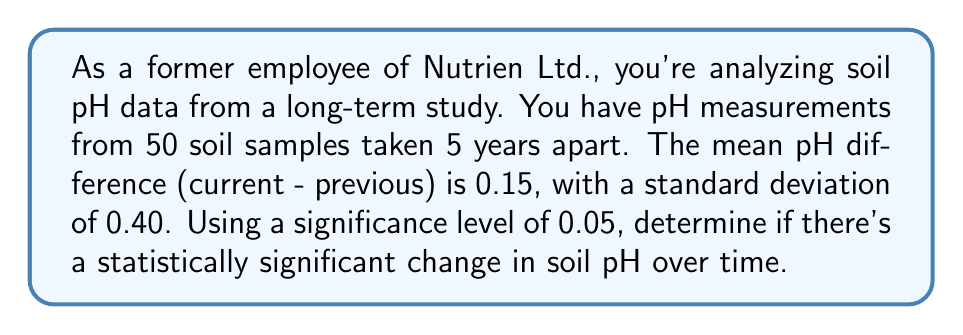Solve this math problem. To determine if there's a statistically significant change in soil pH over time, we'll use a paired t-test. Here are the steps:

1. State the hypotheses:
   $H_0: \mu_d = 0$ (null hypothesis: no significant change in pH)
   $H_a: \mu_d \neq 0$ (alternative hypothesis: significant change in pH)

2. Calculate the t-statistic:
   $t = \frac{\bar{d}}{s_d / \sqrt{n}}$
   where $\bar{d}$ is the mean difference, $s_d$ is the standard deviation of the differences, and $n$ is the sample size.

   $t = \frac{0.15}{0.40 / \sqrt{50}} = \frac{0.15}{0.0566} = 2.65$

3. Determine the critical t-value:
   For a two-tailed test with $\alpha = 0.05$ and $df = 49$, the critical t-value is approximately $\pm 2.01$.

4. Compare the calculated t-statistic to the critical value:
   $|2.65| > 2.01$

5. Calculate the p-value:
   Using a t-distribution calculator or table, we find that the p-value for $t = 2.65$ with $df = 49$ is approximately 0.0108.

6. Make a decision:
   Since $|t| > t_{critical}$ and $p < \alpha$, we reject the null hypothesis.
Answer: Statistically significant change in soil pH (p = 0.0108) 